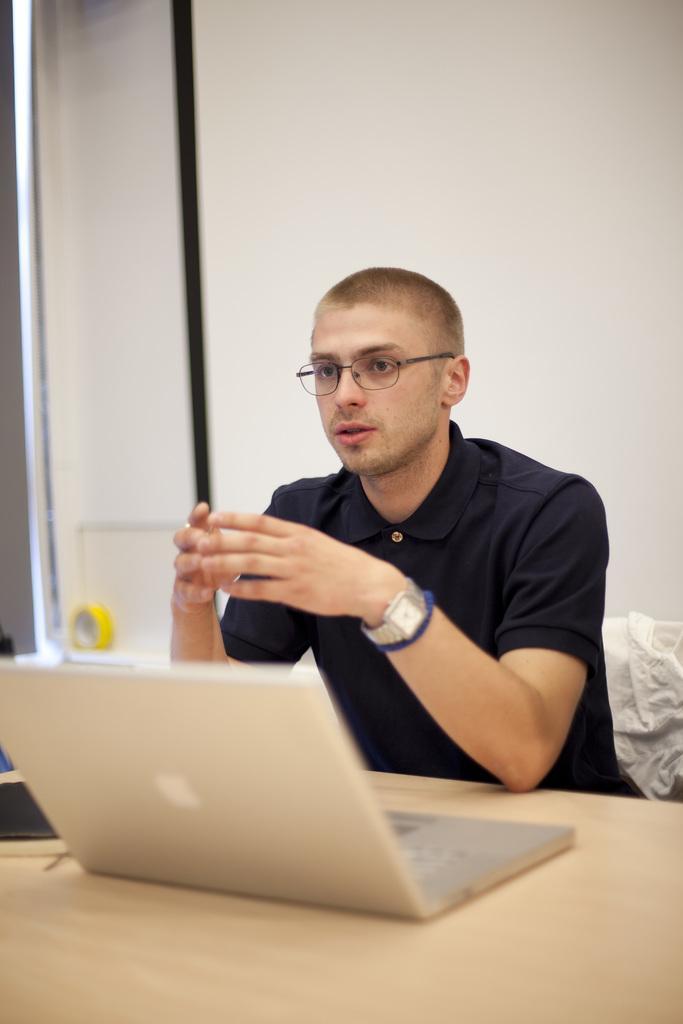Can you describe this image briefly? Here we can see a man wearing spectacles, watch, sitting on a chair in front of a table and on the table we can see laptop. Background is white in colour. 